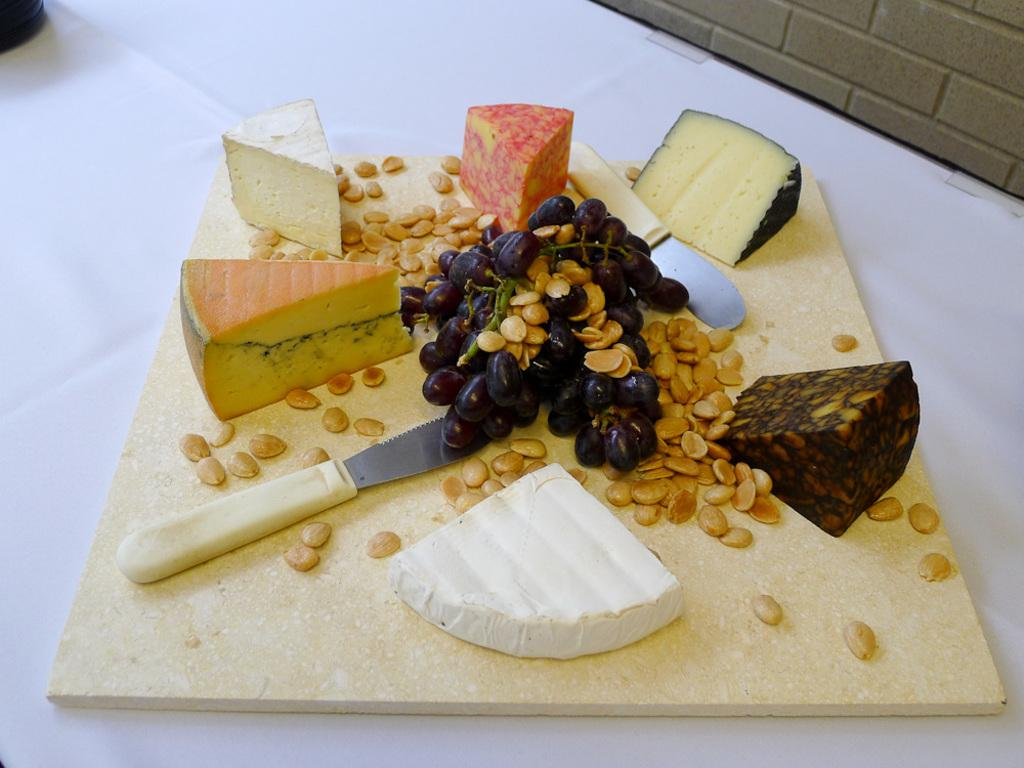What type of food items can be seen in the image? There are pieces of fruit in the image. Where are the fruit placed? The fruit is placed on a chopping board. What utensil is present in the image? There is a knife in the image. How much money is being exchanged between the fruit and the knife in the image? There is no money or exchange of money present in the image; it features fruit on a chopping board and a knife. Can you describe how the fruit is stretching in the image? The fruit is not stretching in the image; it is simply placed on the chopping board. 